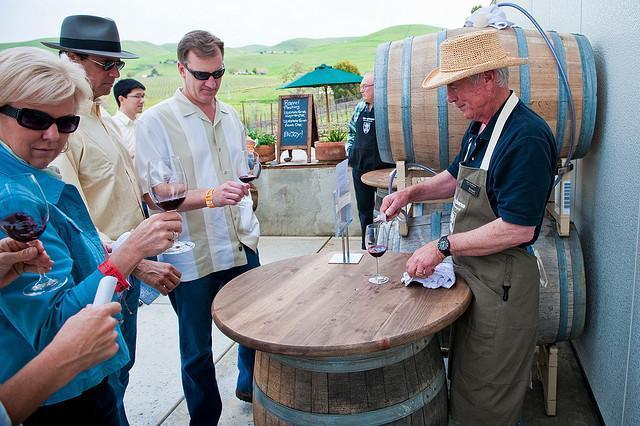How many wooden barrels do you see?
Give a very brief answer. 3. How many wine glasses are there?
Give a very brief answer. 2. How many people can you see?
Give a very brief answer. 6. 